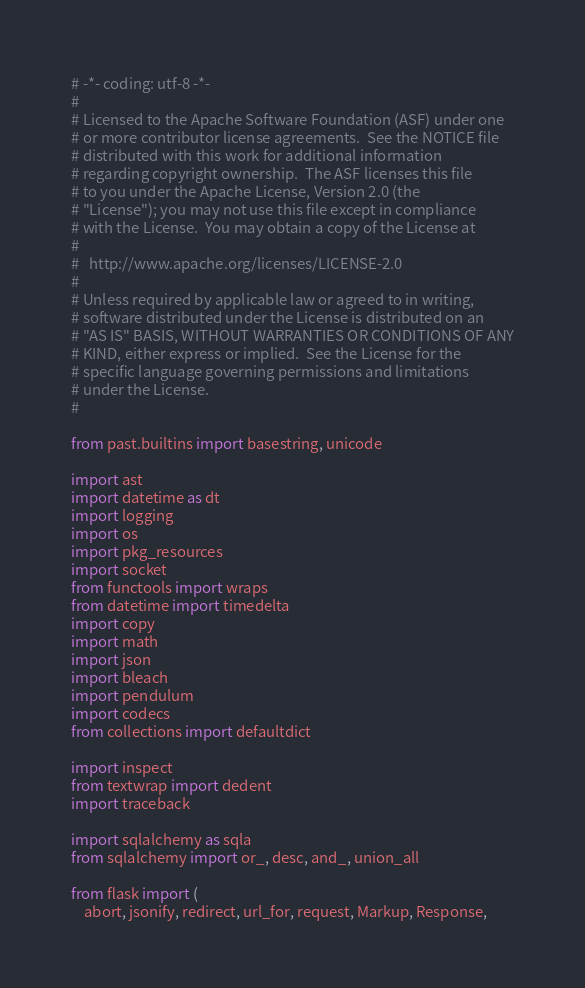<code> <loc_0><loc_0><loc_500><loc_500><_Python_># -*- coding: utf-8 -*-
#
# Licensed to the Apache Software Foundation (ASF) under one
# or more contributor license agreements.  See the NOTICE file
# distributed with this work for additional information
# regarding copyright ownership.  The ASF licenses this file
# to you under the Apache License, Version 2.0 (the
# "License"); you may not use this file except in compliance
# with the License.  You may obtain a copy of the License at
#
#   http://www.apache.org/licenses/LICENSE-2.0
#
# Unless required by applicable law or agreed to in writing,
# software distributed under the License is distributed on an
# "AS IS" BASIS, WITHOUT WARRANTIES OR CONDITIONS OF ANY
# KIND, either express or implied.  See the License for the
# specific language governing permissions and limitations
# under the License.
#

from past.builtins import basestring, unicode

import ast
import datetime as dt
import logging
import os
import pkg_resources
import socket
from functools import wraps
from datetime import timedelta
import copy
import math
import json
import bleach
import pendulum
import codecs
from collections import defaultdict

import inspect
from textwrap import dedent
import traceback

import sqlalchemy as sqla
from sqlalchemy import or_, desc, and_, union_all

from flask import (
    abort, jsonify, redirect, url_for, request, Markup, Response,</code> 